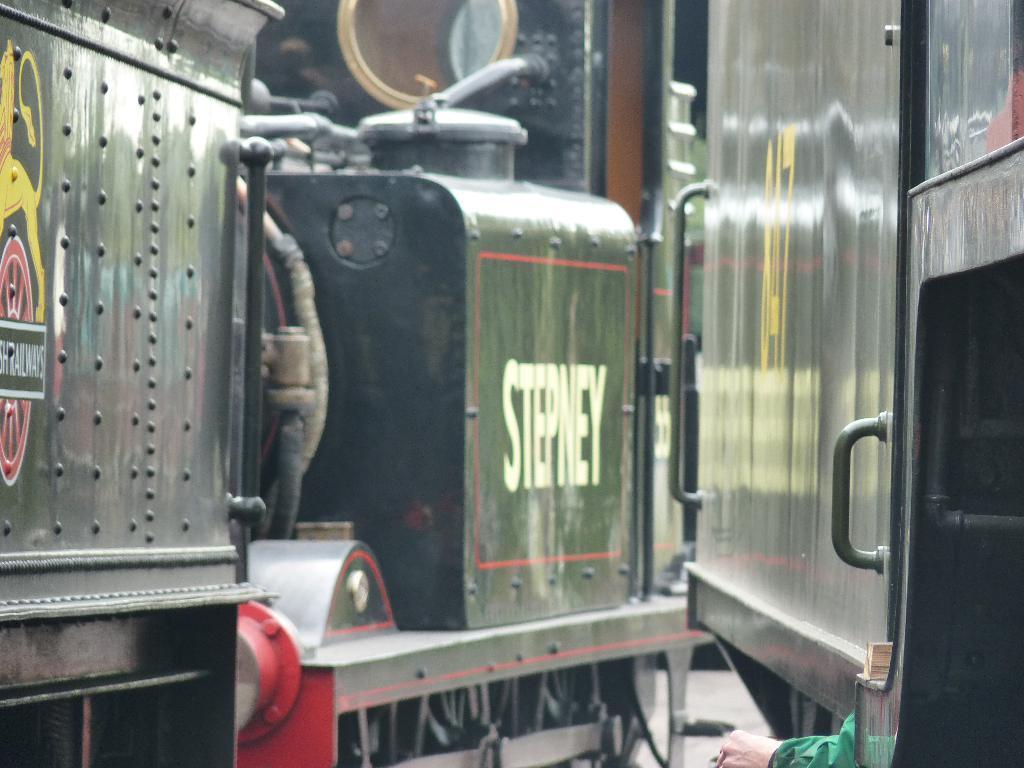Can you describe this image briefly? In this image we can see trains, text and an image on the train and a person's hand. 